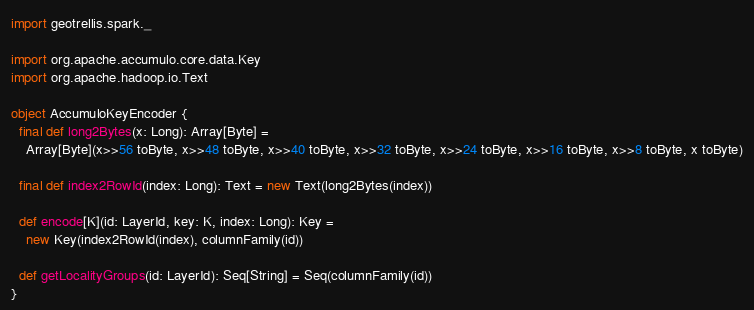<code> <loc_0><loc_0><loc_500><loc_500><_Scala_>
import geotrellis.spark._

import org.apache.accumulo.core.data.Key
import org.apache.hadoop.io.Text

object AccumuloKeyEncoder {
  final def long2Bytes(x: Long): Array[Byte] =
    Array[Byte](x>>56 toByte, x>>48 toByte, x>>40 toByte, x>>32 toByte, x>>24 toByte, x>>16 toByte, x>>8 toByte, x toByte)

  final def index2RowId(index: Long): Text = new Text(long2Bytes(index))

  def encode[K](id: LayerId, key: K, index: Long): Key =
    new Key(index2RowId(index), columnFamily(id))

  def getLocalityGroups(id: LayerId): Seq[String] = Seq(columnFamily(id))
}
</code> 